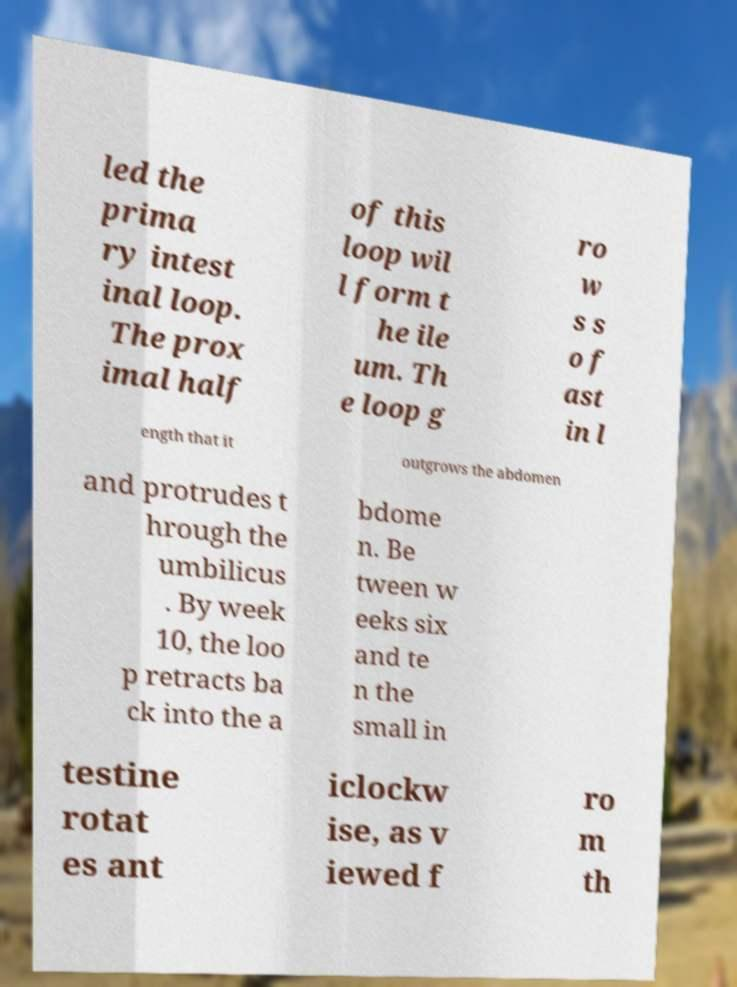Please identify and transcribe the text found in this image. led the prima ry intest inal loop. The prox imal half of this loop wil l form t he ile um. Th e loop g ro w s s o f ast in l ength that it outgrows the abdomen and protrudes t hrough the umbilicus . By week 10, the loo p retracts ba ck into the a bdome n. Be tween w eeks six and te n the small in testine rotat es ant iclockw ise, as v iewed f ro m th 